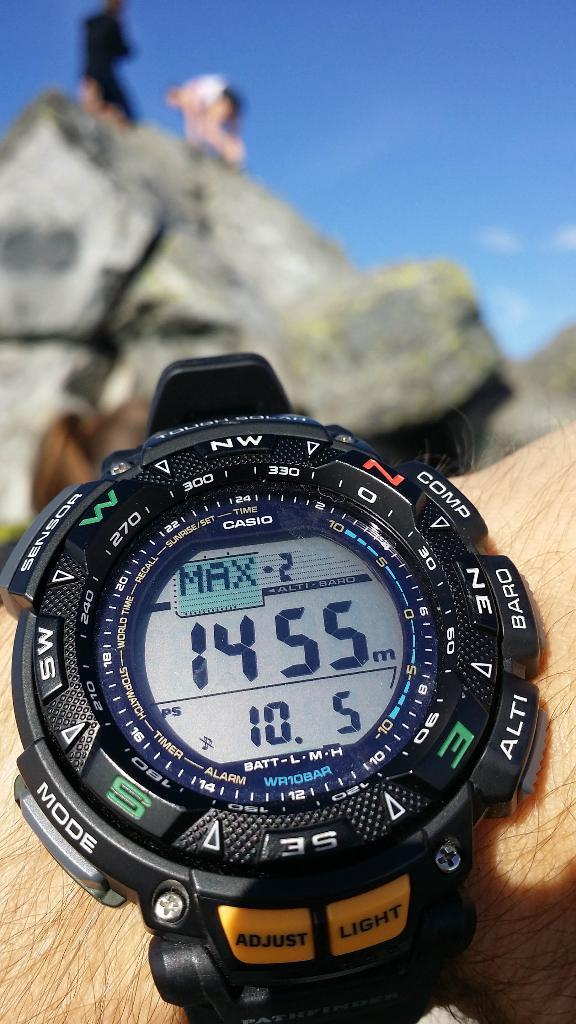<image>
Present a compact description of the photo's key features. A Casio watch displays the time of 14:55 and has Max 2 at the top. 